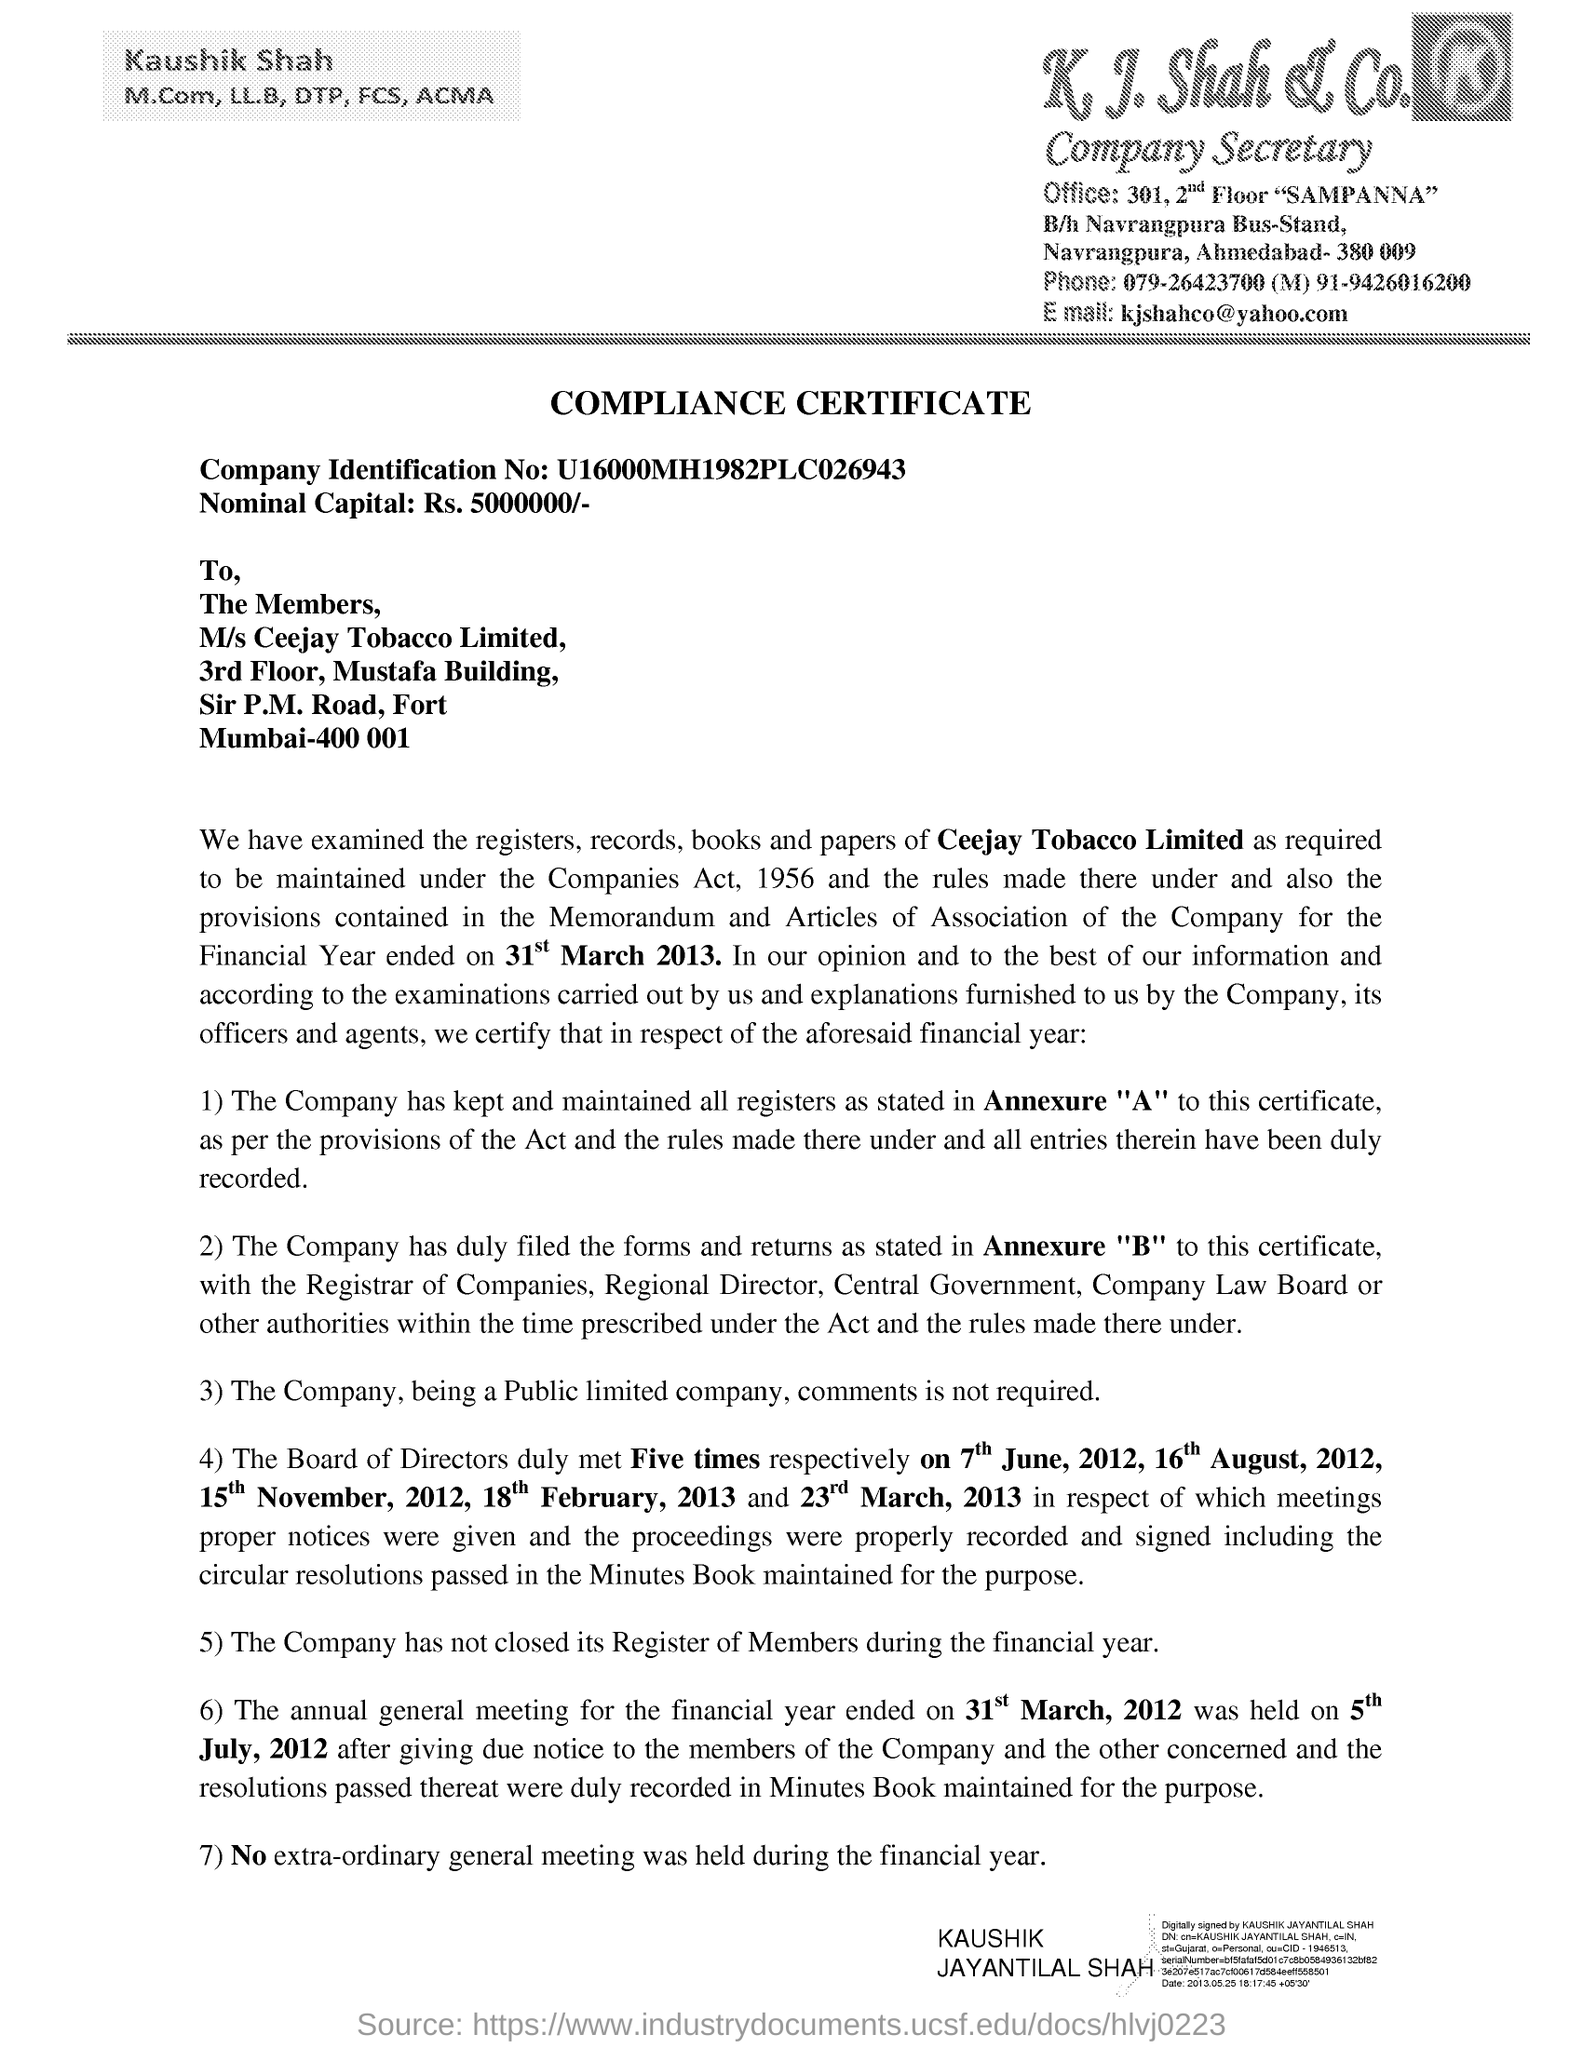What is the Company Identification No given in the document?
 u16000mh1982plc026943 